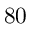<formula> <loc_0><loc_0><loc_500><loc_500>8 0</formula> 